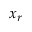Convert formula to latex. <formula><loc_0><loc_0><loc_500><loc_500>x _ { r }</formula> 